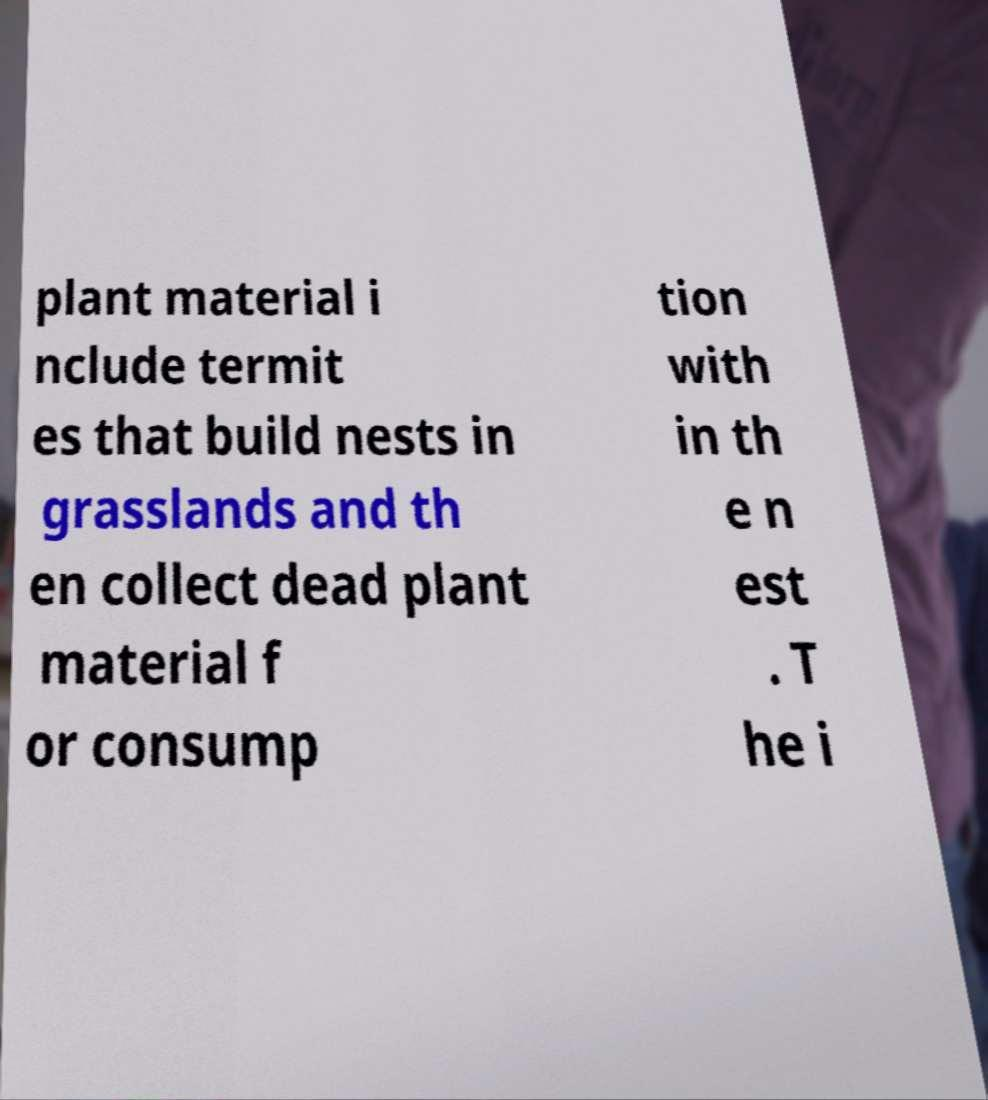I need the written content from this picture converted into text. Can you do that? plant material i nclude termit es that build nests in grasslands and th en collect dead plant material f or consump tion with in th e n est . T he i 